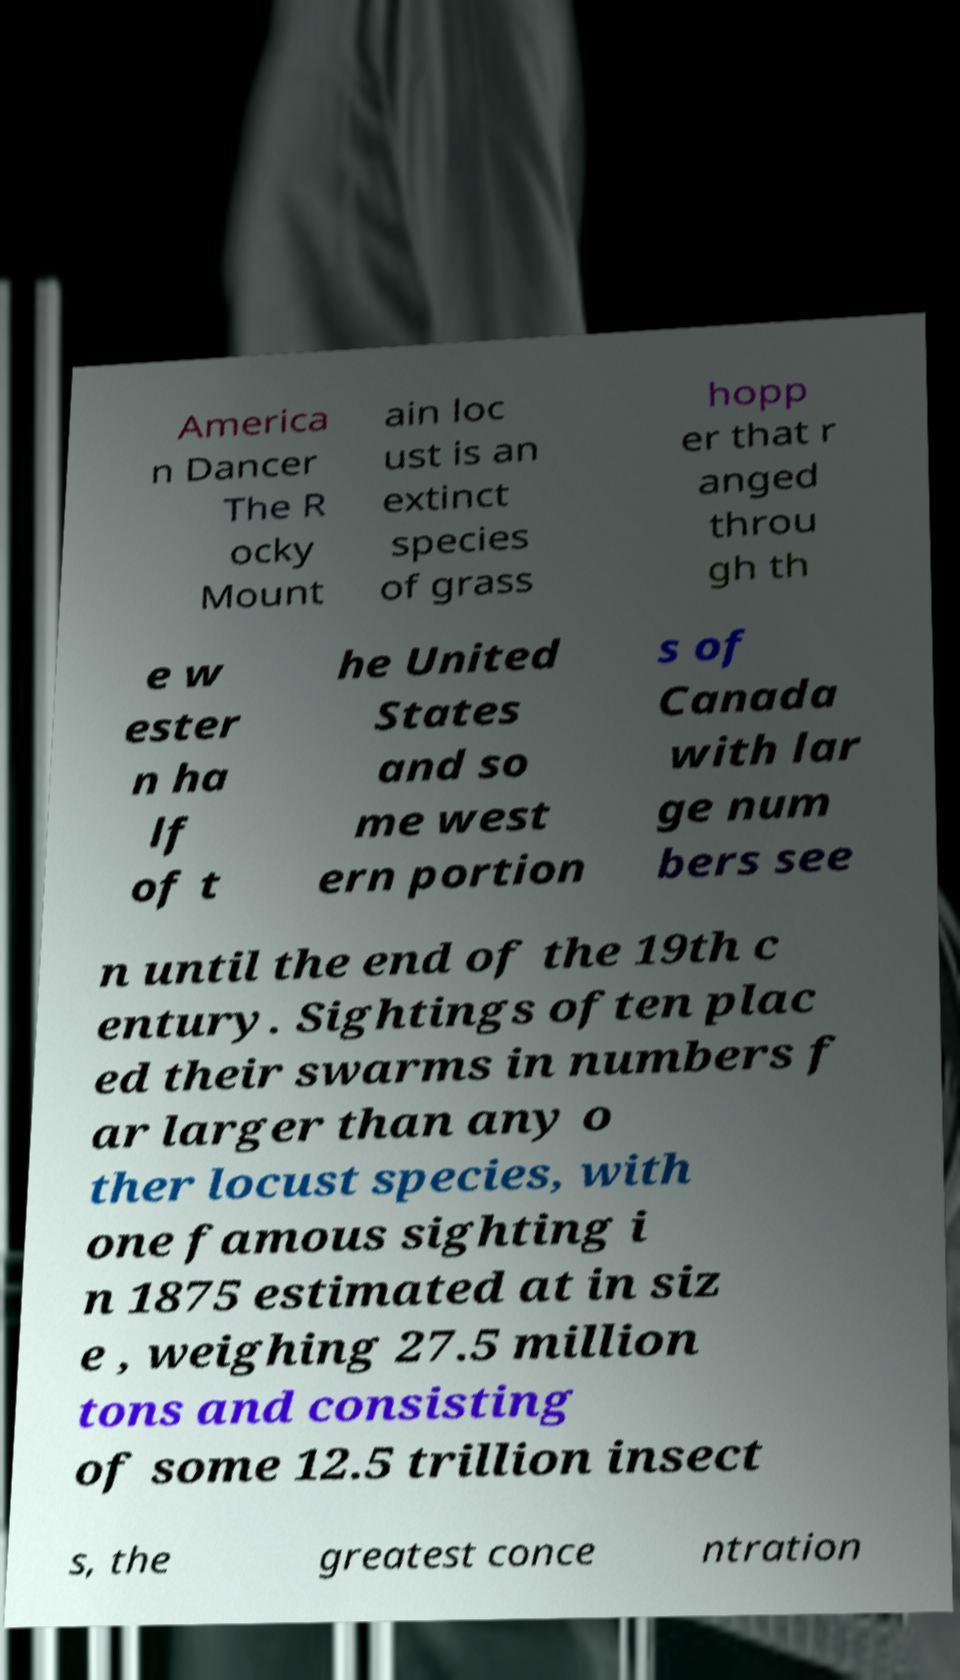There's text embedded in this image that I need extracted. Can you transcribe it verbatim? America n Dancer The R ocky Mount ain loc ust is an extinct species of grass hopp er that r anged throu gh th e w ester n ha lf of t he United States and so me west ern portion s of Canada with lar ge num bers see n until the end of the 19th c entury. Sightings often plac ed their swarms in numbers f ar larger than any o ther locust species, with one famous sighting i n 1875 estimated at in siz e , weighing 27.5 million tons and consisting of some 12.5 trillion insect s, the greatest conce ntration 